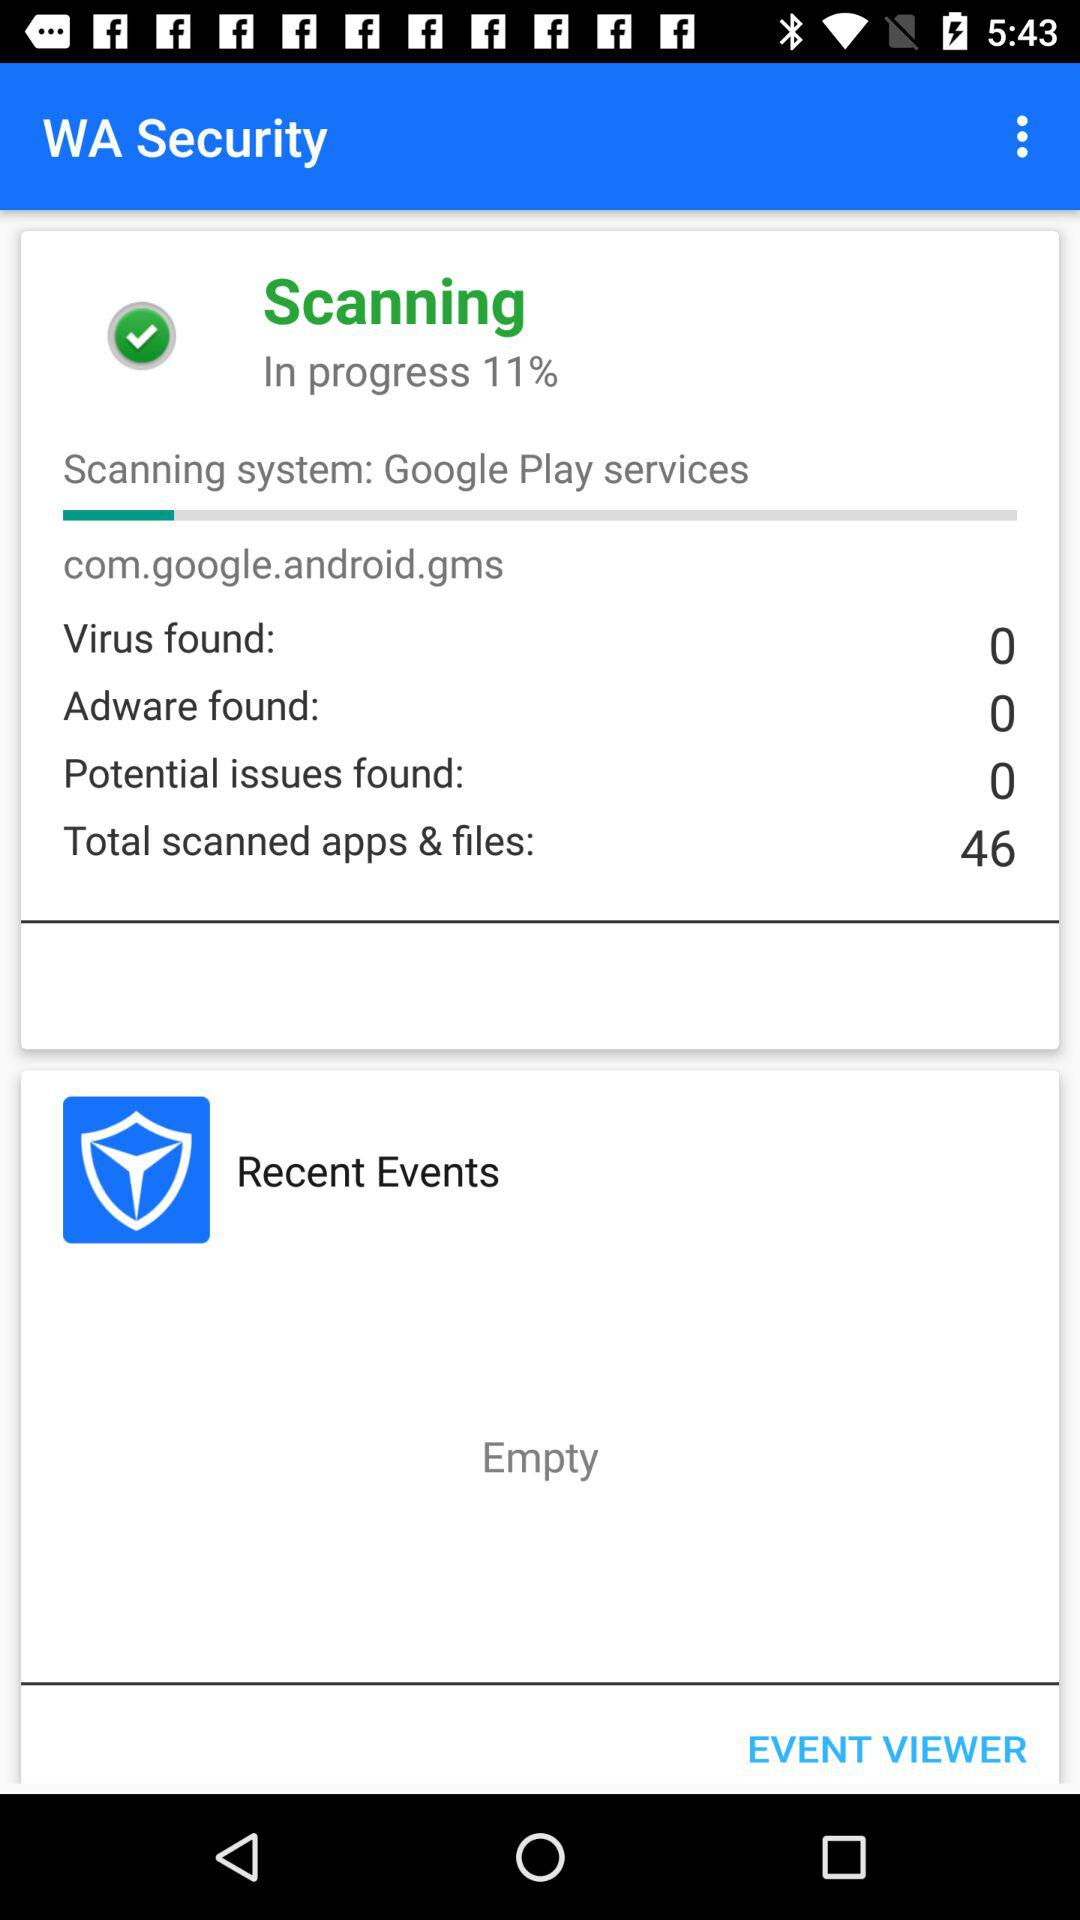What is the count of found viruses? The count is 0. 